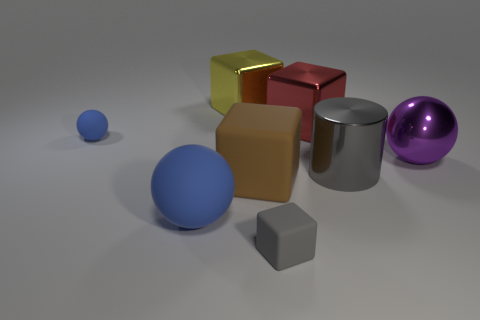Subtract all yellow cylinders. Subtract all blue balls. How many cylinders are left? 1 Add 1 big brown cylinders. How many objects exist? 9 Subtract all cylinders. How many objects are left? 7 Add 6 tiny yellow rubber objects. How many tiny yellow rubber objects exist? 6 Subtract 0 purple blocks. How many objects are left? 8 Subtract all small blue rubber objects. Subtract all yellow things. How many objects are left? 6 Add 1 tiny rubber balls. How many tiny rubber balls are left? 2 